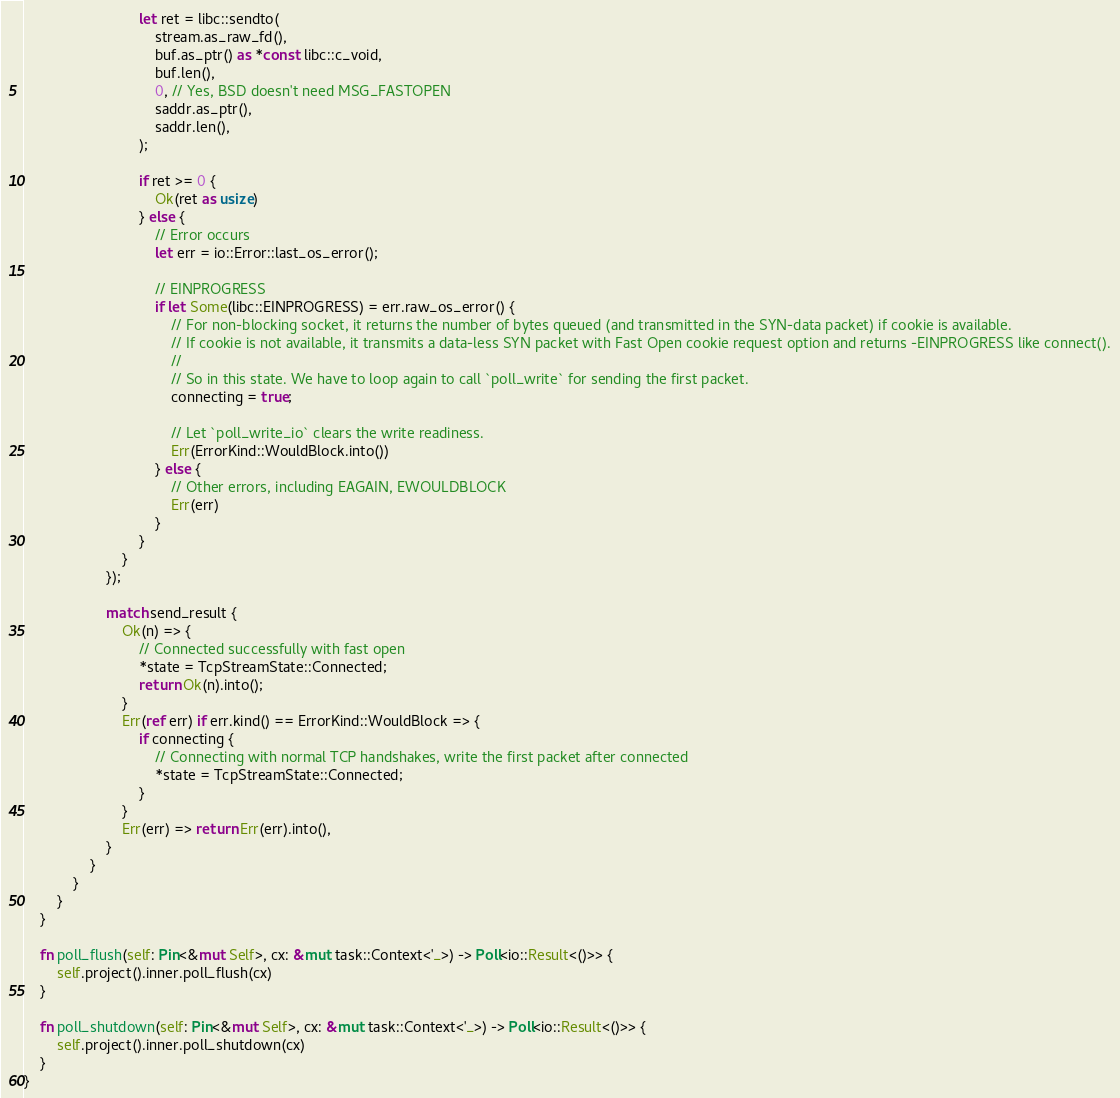<code> <loc_0><loc_0><loc_500><loc_500><_Rust_>                            let ret = libc::sendto(
                                stream.as_raw_fd(),
                                buf.as_ptr() as *const libc::c_void,
                                buf.len(),
                                0, // Yes, BSD doesn't need MSG_FASTOPEN
                                saddr.as_ptr(),
                                saddr.len(),
                            );

                            if ret >= 0 {
                                Ok(ret as usize)
                            } else {
                                // Error occurs
                                let err = io::Error::last_os_error();

                                // EINPROGRESS
                                if let Some(libc::EINPROGRESS) = err.raw_os_error() {
                                    // For non-blocking socket, it returns the number of bytes queued (and transmitted in the SYN-data packet) if cookie is available.
                                    // If cookie is not available, it transmits a data-less SYN packet with Fast Open cookie request option and returns -EINPROGRESS like connect().
                                    //
                                    // So in this state. We have to loop again to call `poll_write` for sending the first packet.
                                    connecting = true;

                                    // Let `poll_write_io` clears the write readiness.
                                    Err(ErrorKind::WouldBlock.into())
                                } else {
                                    // Other errors, including EAGAIN, EWOULDBLOCK
                                    Err(err)
                                }
                            }
                        }
                    });

                    match send_result {
                        Ok(n) => {
                            // Connected successfully with fast open
                            *state = TcpStreamState::Connected;
                            return Ok(n).into();
                        }
                        Err(ref err) if err.kind() == ErrorKind::WouldBlock => {
                            if connecting {
                                // Connecting with normal TCP handshakes, write the first packet after connected
                                *state = TcpStreamState::Connected;
                            }
                        }
                        Err(err) => return Err(err).into(),
                    }
                }
            }
        }
    }

    fn poll_flush(self: Pin<&mut Self>, cx: &mut task::Context<'_>) -> Poll<io::Result<()>> {
        self.project().inner.poll_flush(cx)
    }

    fn poll_shutdown(self: Pin<&mut Self>, cx: &mut task::Context<'_>) -> Poll<io::Result<()>> {
        self.project().inner.poll_shutdown(cx)
    }
}
</code> 